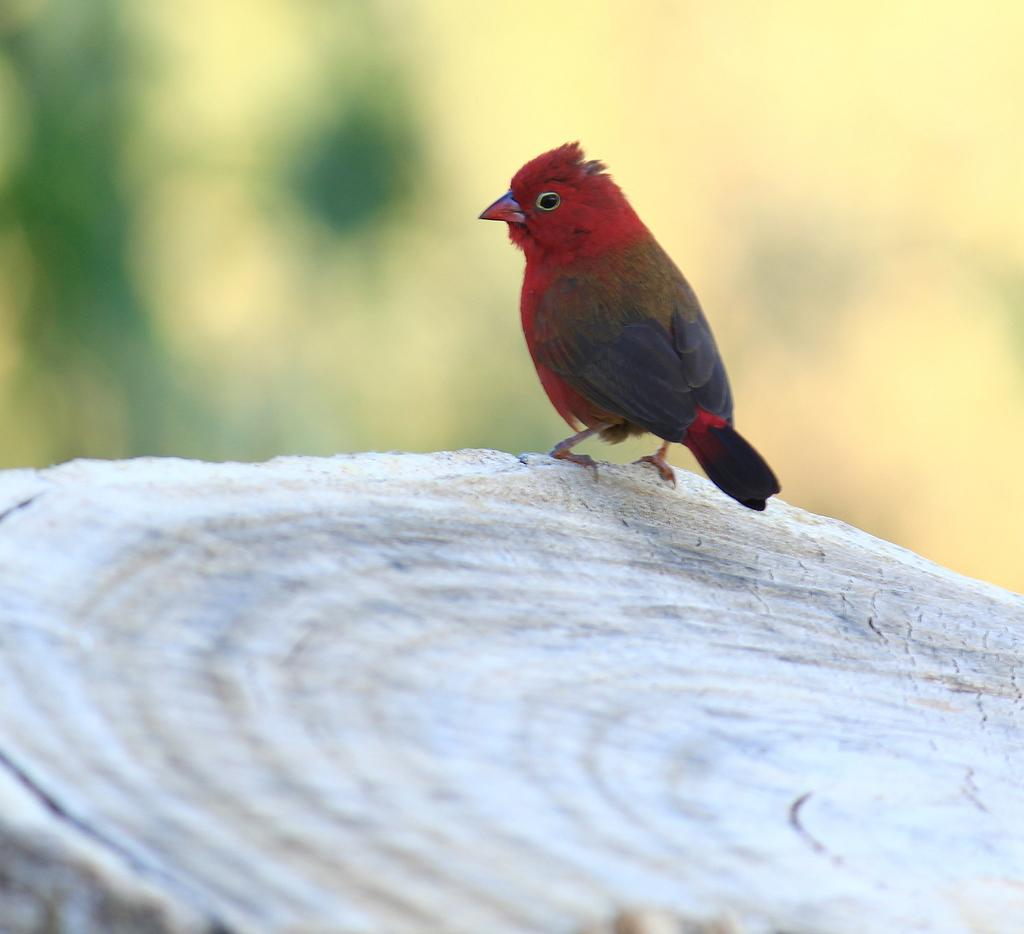What type of animal is in the image? There is a bird in the image. Where is the bird located? The bird is on a wooden log. Can you describe the background of the image? The background of the image is blurred. What is the bird's income in the image? There is no information about the bird's income in the image. Birds do not have income. 